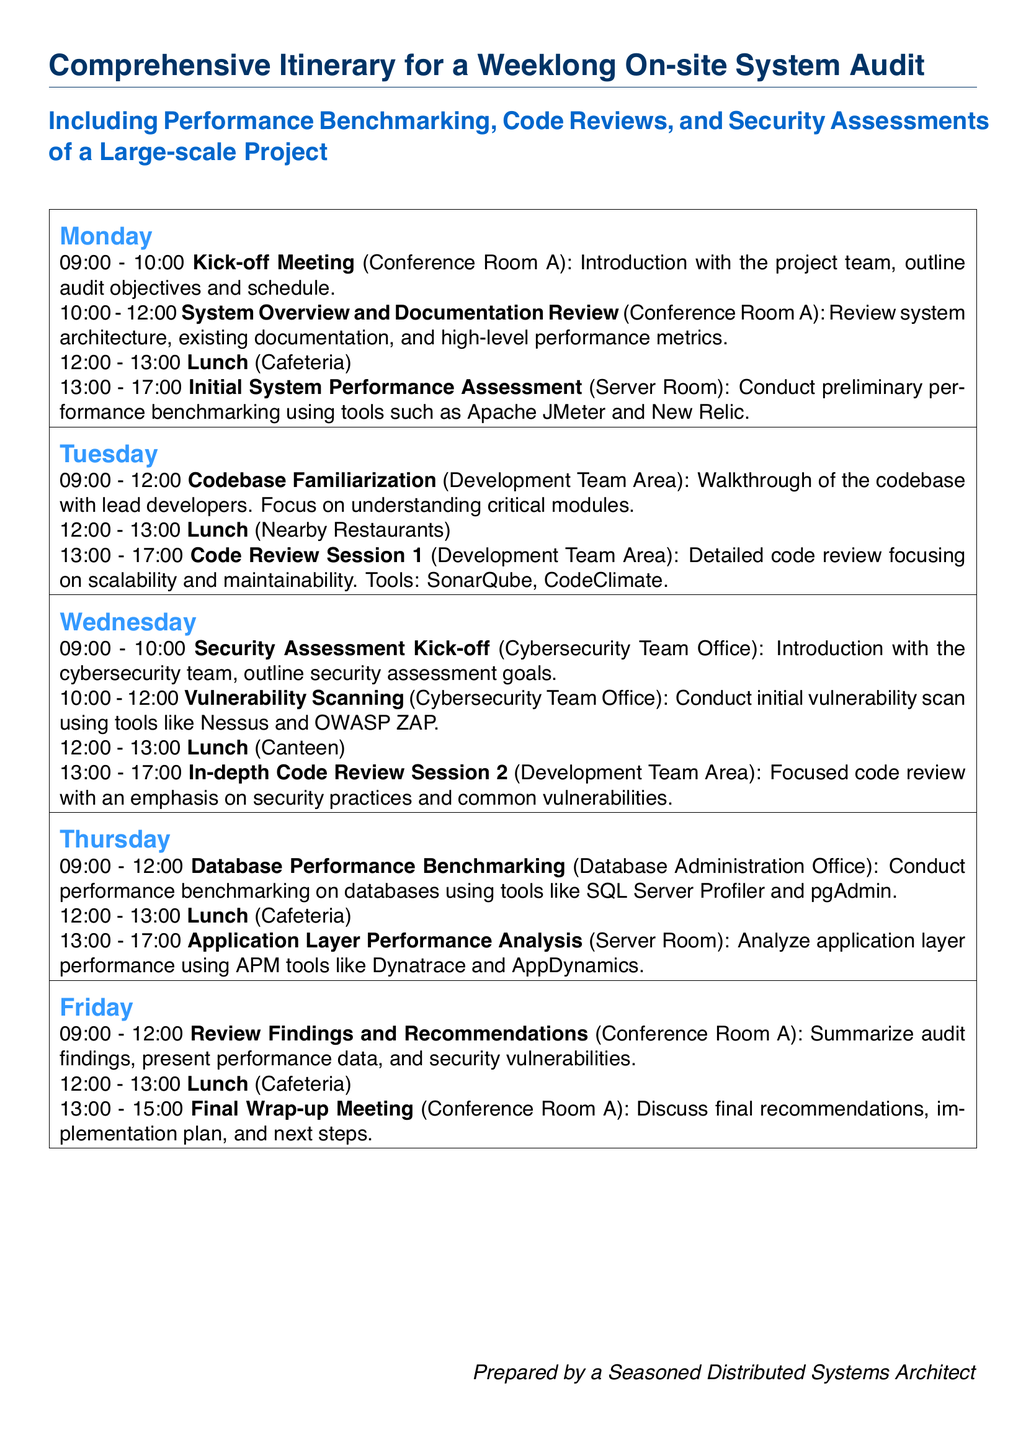What is the first activity on Monday? The first activity listed for Monday is the Kick-off Meeting starting at 09:00.
Answer: Kick-off Meeting What tool is mentioned for initial vulnerability scanning? The document lists Nessus and OWASP ZAP as tools for vulnerability scanning.
Answer: Nessus How long is the lunch break on Tuesday? The lunch break is scheduled for one hour from 12:00 to 13:00.
Answer: 1 hour What time does the review findings session occur on Friday? The review findings session takes place from 09:00 to 12:00 on Friday.
Answer: 09:00 - 12:00 Which day includes Database Performance Benchmarking? The Database Performance Benchmarking is scheduled for Thursday.
Answer: Thursday What is the main focus of the code review session on Tuesday? The focus is on scalability and maintainability of the code.
Answer: Scalability and maintainability Who prepares the document? The document notes that it is prepared by a seasoned distributed systems architect.
Answer: A seasoned distributed systems architect Which office conducts the security assessment kick-off? The security assessment kick-off is held in the Cybersecurity Team Office.
Answer: Cybersecurity Team Office What tool is used for application layer performance analysis? The document mentions Dynatrace and AppDynamics for performance analysis.
Answer: Dynatrace and AppDynamics 